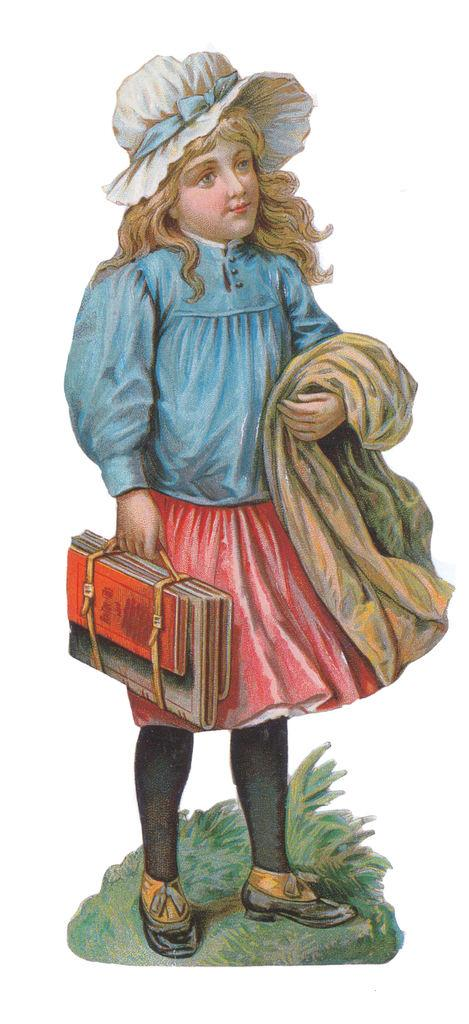What type of artwork is depicted in the image? The image appears to be a painting. Who or what is the main subject of the painting? There is a girl in the painting. What is the girl holding in the painting? The girl is holding a bag and a cloth. What is the girl's posture in the painting? The girl is standing in the painting. What type of terrain is visible in the painting? There is grass in the painting. What is the color of the background in the painting? The background of the painting is white in color. What advice does the girl in the painting give to the basketball player? There is no basketball player present in the painting, and the girl does not give any advice. 